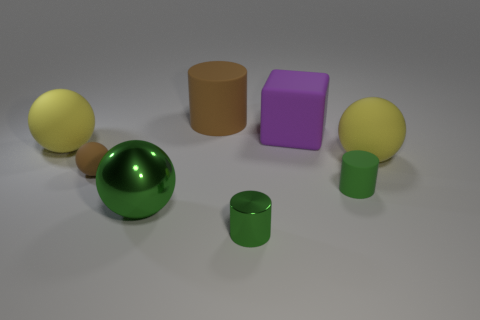Is the color of the matte cylinder that is on the right side of the green metal cylinder the same as the small cylinder that is to the left of the purple object?
Provide a short and direct response. Yes. There is a matte cylinder to the right of the small shiny cylinder; is its color the same as the shiny ball?
Your response must be concise. Yes. What number of small rubber things are left of the brown thing in front of the purple block behind the small brown thing?
Give a very brief answer. 0. What material is the object that is the same color as the tiny matte ball?
Keep it short and to the point. Rubber. Is the number of large brown rubber things greater than the number of gray shiny cylinders?
Your answer should be very brief. Yes. Is the metal cylinder the same size as the green sphere?
Ensure brevity in your answer.  No. What number of things are gray metal objects or rubber cylinders?
Keep it short and to the point. 2. What is the shape of the yellow rubber object that is to the left of the brown rubber object that is in front of the brown thing behind the large block?
Offer a very short reply. Sphere. Is the material of the small brown ball behind the green shiny sphere the same as the sphere that is to the right of the green rubber thing?
Offer a terse response. Yes. What is the material of the big green object that is the same shape as the small brown thing?
Provide a short and direct response. Metal. 